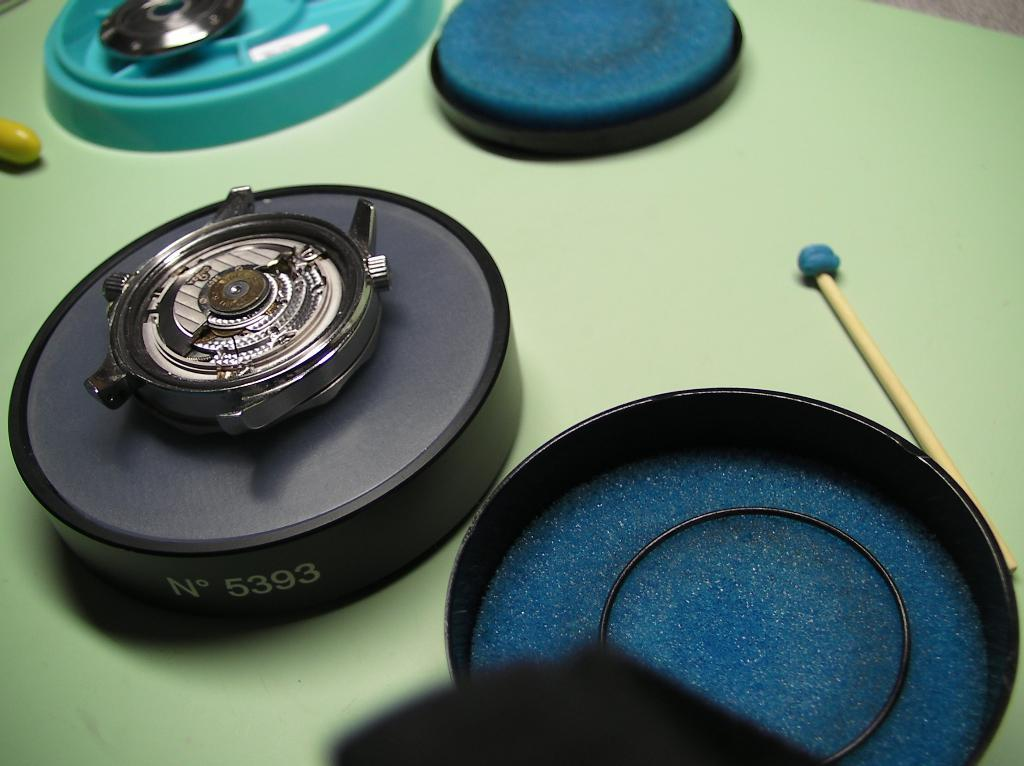<image>
Present a compact description of the photo's key features. A watch on a circular thing that says No 5393 on the outer rim. 